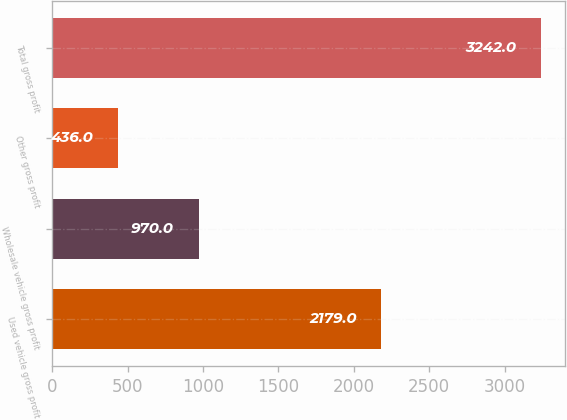Convert chart to OTSL. <chart><loc_0><loc_0><loc_500><loc_500><bar_chart><fcel>Used vehicle gross profit<fcel>Wholesale vehicle gross profit<fcel>Other gross profit<fcel>Total gross profit<nl><fcel>2179<fcel>970<fcel>436<fcel>3242<nl></chart> 